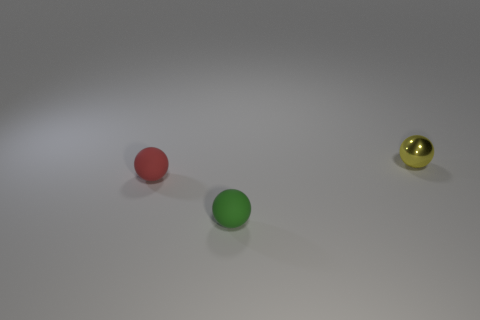Are there fewer small yellow objects that are to the right of the small green matte object than small balls that are to the left of the tiny metallic thing?
Provide a short and direct response. Yes. Is the number of red spheres in front of the red object less than the number of small purple matte things?
Ensure brevity in your answer.  No. Do the yellow object and the green object have the same material?
Give a very brief answer. No. What number of red things have the same material as the small red ball?
Give a very brief answer. 0. The other tiny object that is made of the same material as the small red object is what color?
Make the answer very short. Green. What shape is the red matte object?
Ensure brevity in your answer.  Sphere. What is the material of the green sphere in front of the tiny red object?
Make the answer very short. Rubber. Is there another tiny metallic ball of the same color as the shiny ball?
Provide a short and direct response. No. The yellow metal thing that is the same size as the red ball is what shape?
Your response must be concise. Sphere. There is a tiny matte thing that is in front of the small red ball; what color is it?
Ensure brevity in your answer.  Green. 